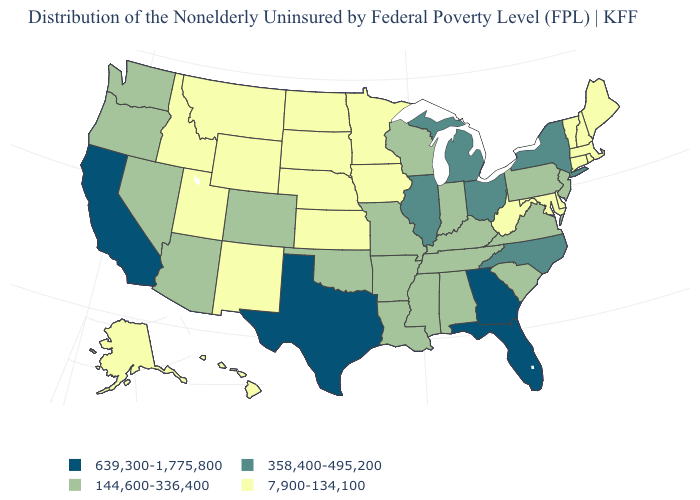Name the states that have a value in the range 7,900-134,100?
Concise answer only. Alaska, Connecticut, Delaware, Hawaii, Idaho, Iowa, Kansas, Maine, Maryland, Massachusetts, Minnesota, Montana, Nebraska, New Hampshire, New Mexico, North Dakota, Rhode Island, South Dakota, Utah, Vermont, West Virginia, Wyoming. Does the first symbol in the legend represent the smallest category?
Be succinct. No. Among the states that border North Dakota , which have the lowest value?
Give a very brief answer. Minnesota, Montana, South Dakota. What is the value of Arkansas?
Quick response, please. 144,600-336,400. What is the value of Illinois?
Give a very brief answer. 358,400-495,200. How many symbols are there in the legend?
Be succinct. 4. What is the value of Illinois?
Quick response, please. 358,400-495,200. What is the lowest value in the USA?
Concise answer only. 7,900-134,100. Does the map have missing data?
Be succinct. No. Among the states that border Utah , which have the highest value?
Short answer required. Arizona, Colorado, Nevada. Among the states that border Massachusetts , does Vermont have the lowest value?
Write a very short answer. Yes. What is the value of North Dakota?
Answer briefly. 7,900-134,100. What is the value of Idaho?
Be succinct. 7,900-134,100. What is the value of Hawaii?
Write a very short answer. 7,900-134,100. What is the value of Tennessee?
Short answer required. 144,600-336,400. 